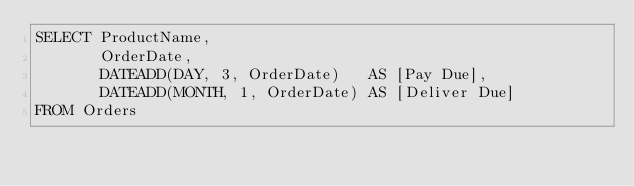Convert code to text. <code><loc_0><loc_0><loc_500><loc_500><_SQL_>SELECT ProductName,
       OrderDate,
       DATEADD(DAY, 3, OrderDate)   AS [Pay Due],
       DATEADD(MONTH, 1, OrderDate) AS [Deliver Due]
FROM Orders</code> 